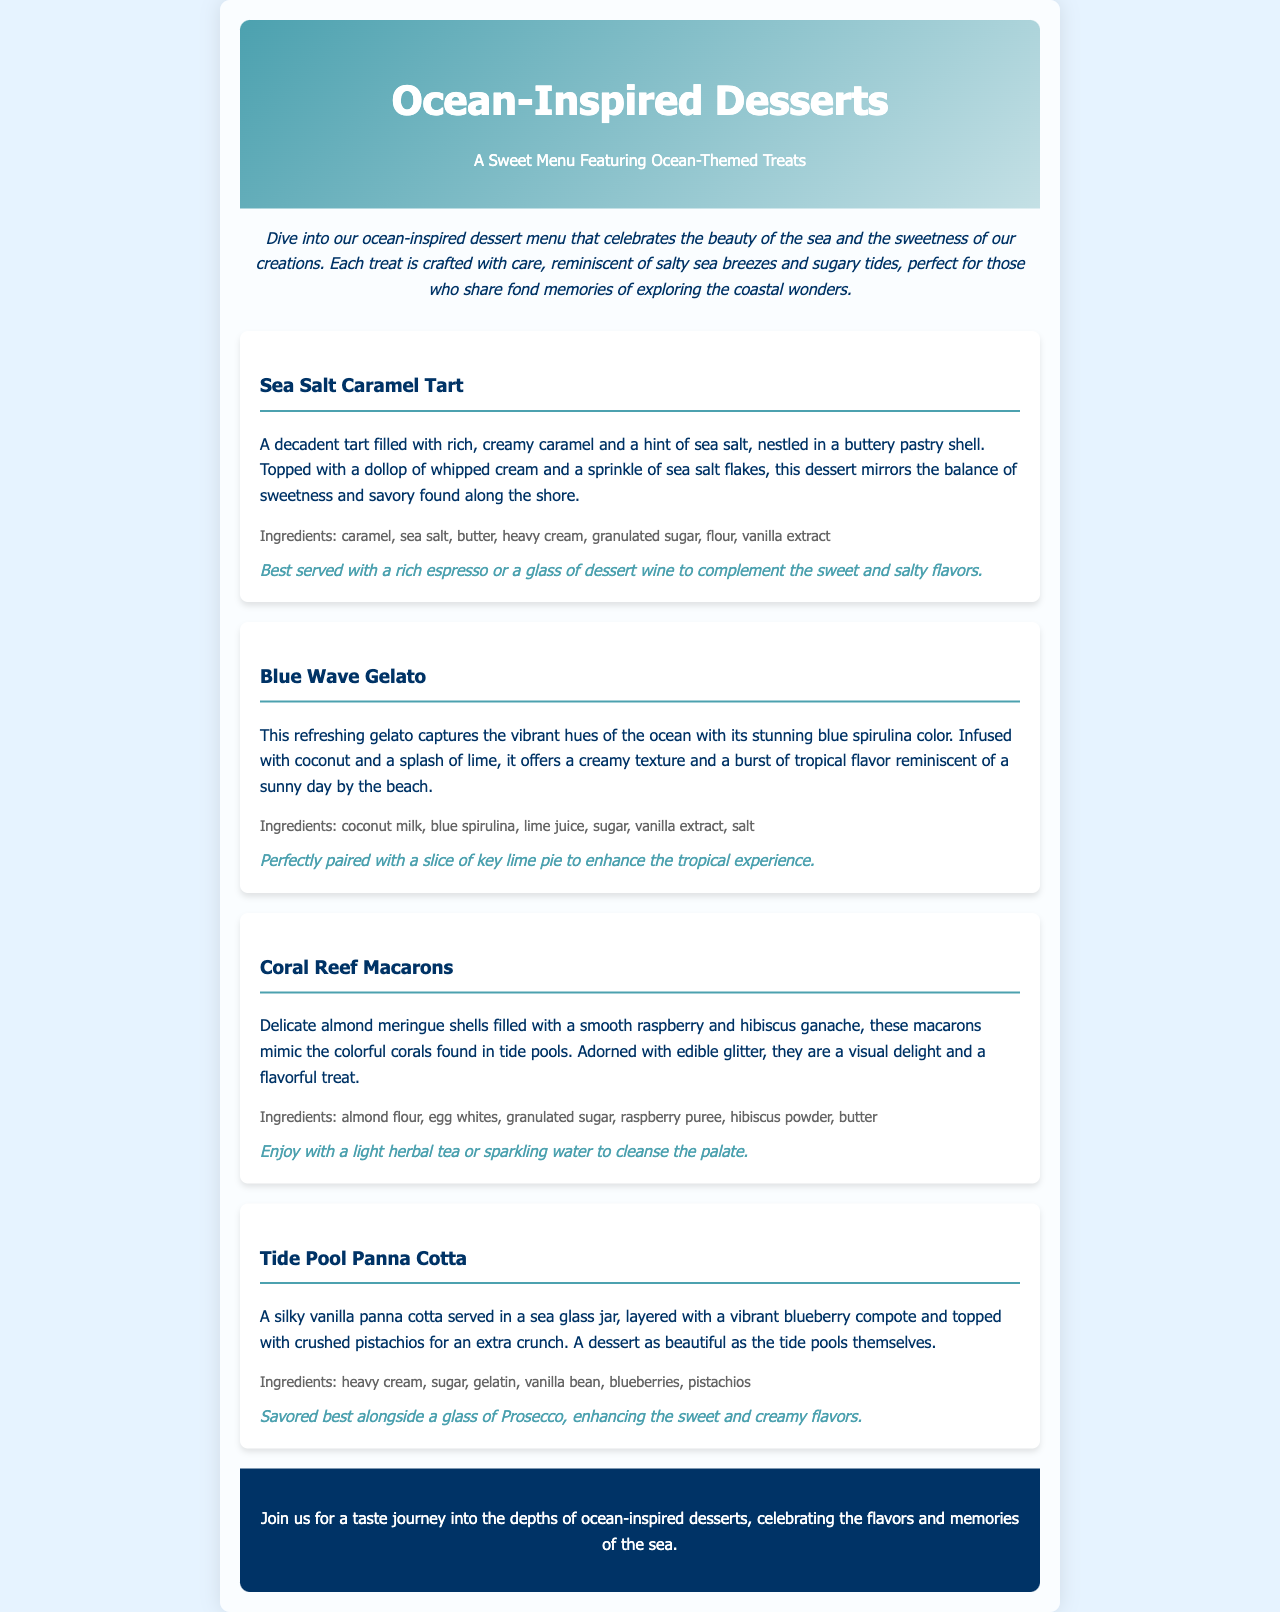What is the title of the menu? The title is presented prominently at the top of the menu.
Answer: Ocean-Inspired Desserts How many desserts are listed in the menu? The menu includes a clear number of desserts presented in separate sections.
Answer: Four What is the main ingredient in the Sea Salt Caramel Tart? The description highlights the primary component of this dessert.
Answer: Caramel What flavor is the Blue Wave Gelato infused with? The menu specifies a flavor that the gelato is infused with.
Answer: Coconut Which dessert is described as resembling colorful corals? The menu section describes one dessert in a way that draws a comparison to marine life.
Answer: Coral Reef Macarons What ingredient adds a crunch to the Tide Pool Panna Cotta? The description mentions an ingredient that provides a texture contrast in the dessert.
Answer: Crushed pistachios Which dessert is suggested to be served with a glass of Prosecco? The menu pairs a specific drink with one of the desserts mentioned.
Answer: Tide Pool Panna Cotta What color is the Blue Wave Gelato? The menu describes the color of the gelato in a vivid way.
Answer: Blue What type of tea is recommended with Coral Reef Macarons? The pairing suggests a specific beverage to enjoy with the macarons.
Answer: Herbal tea 